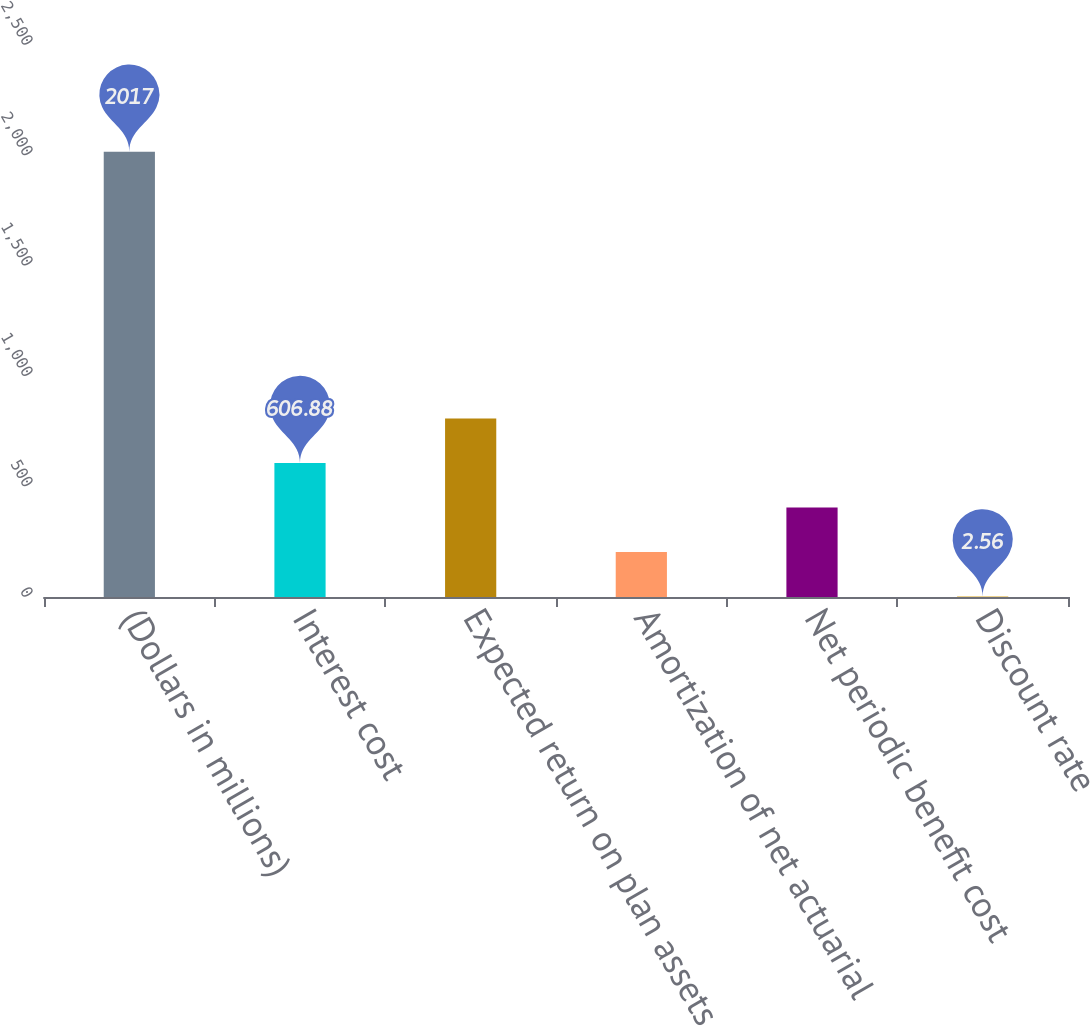Convert chart to OTSL. <chart><loc_0><loc_0><loc_500><loc_500><bar_chart><fcel>(Dollars in millions)<fcel>Interest cost<fcel>Expected return on plan assets<fcel>Amortization of net actuarial<fcel>Net periodic benefit cost<fcel>Discount rate<nl><fcel>2017<fcel>606.88<fcel>808.32<fcel>204<fcel>405.44<fcel>2.56<nl></chart> 